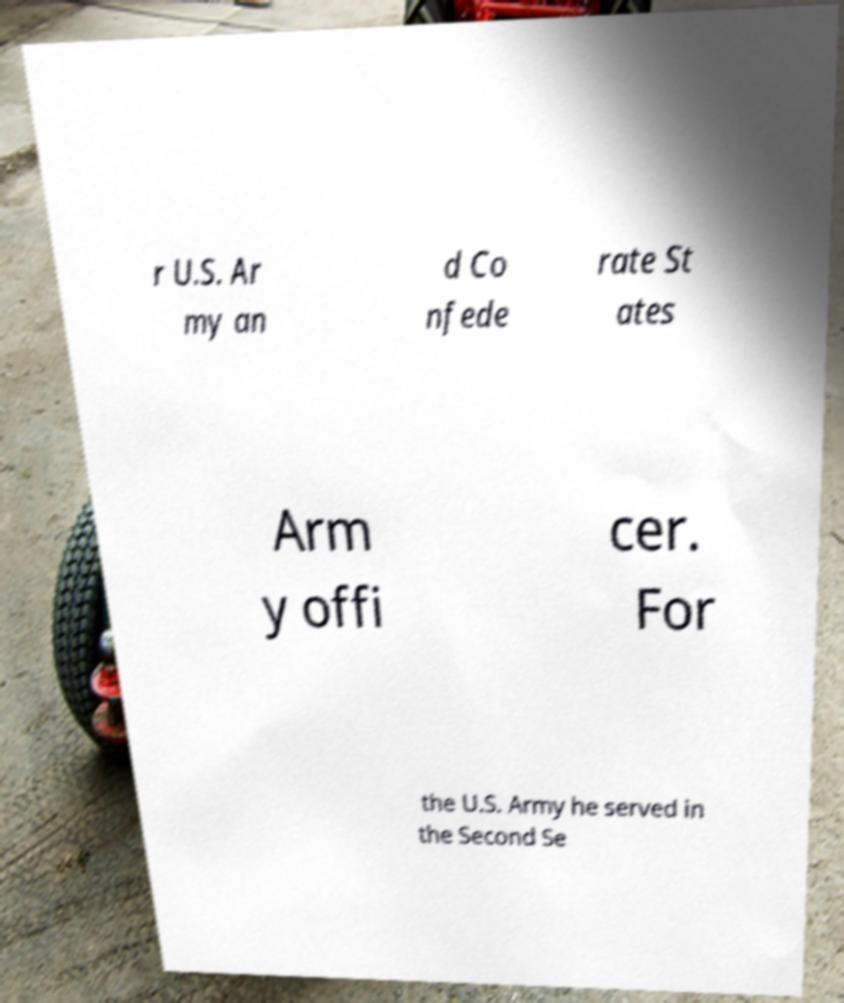Please identify and transcribe the text found in this image. r U.S. Ar my an d Co nfede rate St ates Arm y offi cer. For the U.S. Army he served in the Second Se 